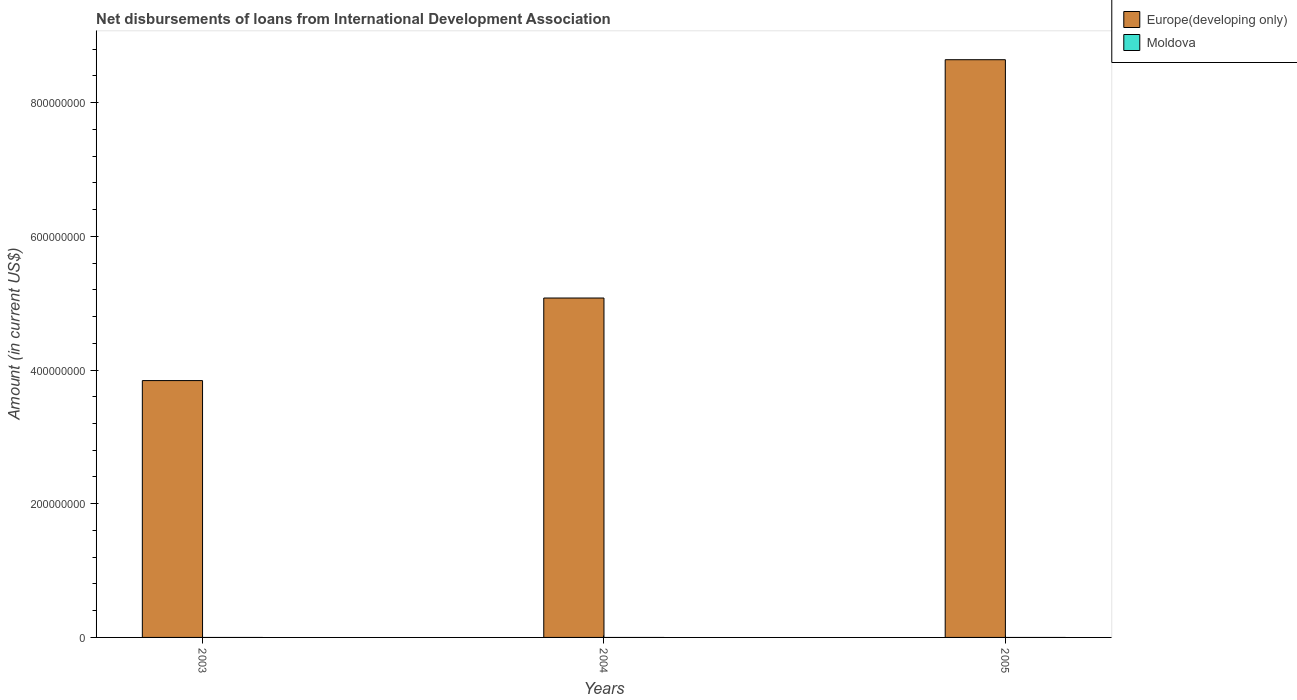What is the label of the 1st group of bars from the left?
Offer a terse response. 2003. What is the amount of loans disbursed in Moldova in 2005?
Your answer should be very brief. 0. Across all years, what is the maximum amount of loans disbursed in Europe(developing only)?
Your response must be concise. 8.64e+08. What is the total amount of loans disbursed in Moldova in the graph?
Offer a terse response. 0. What is the difference between the amount of loans disbursed in Europe(developing only) in 2003 and that in 2004?
Provide a succinct answer. -1.24e+08. What is the difference between the amount of loans disbursed in Moldova in 2005 and the amount of loans disbursed in Europe(developing only) in 2004?
Your response must be concise. -5.08e+08. What is the average amount of loans disbursed in Europe(developing only) per year?
Give a very brief answer. 5.85e+08. What is the ratio of the amount of loans disbursed in Europe(developing only) in 2004 to that in 2005?
Your answer should be very brief. 0.59. Is the amount of loans disbursed in Europe(developing only) in 2003 less than that in 2004?
Keep it short and to the point. Yes. What is the difference between the highest and the second highest amount of loans disbursed in Europe(developing only)?
Give a very brief answer. 3.56e+08. What is the difference between the highest and the lowest amount of loans disbursed in Europe(developing only)?
Provide a short and direct response. 4.80e+08. In how many years, is the amount of loans disbursed in Europe(developing only) greater than the average amount of loans disbursed in Europe(developing only) taken over all years?
Your answer should be compact. 1. How many bars are there?
Offer a very short reply. 3. Are all the bars in the graph horizontal?
Ensure brevity in your answer.  No. How many years are there in the graph?
Keep it short and to the point. 3. What is the difference between two consecutive major ticks on the Y-axis?
Keep it short and to the point. 2.00e+08. Does the graph contain grids?
Give a very brief answer. No. Where does the legend appear in the graph?
Offer a terse response. Top right. How are the legend labels stacked?
Ensure brevity in your answer.  Vertical. What is the title of the graph?
Keep it short and to the point. Net disbursements of loans from International Development Association. What is the label or title of the Y-axis?
Provide a short and direct response. Amount (in current US$). What is the Amount (in current US$) of Europe(developing only) in 2003?
Give a very brief answer. 3.84e+08. What is the Amount (in current US$) in Moldova in 2003?
Offer a terse response. 0. What is the Amount (in current US$) of Europe(developing only) in 2004?
Keep it short and to the point. 5.08e+08. What is the Amount (in current US$) of Europe(developing only) in 2005?
Give a very brief answer. 8.64e+08. What is the Amount (in current US$) of Moldova in 2005?
Your answer should be compact. 0. Across all years, what is the maximum Amount (in current US$) in Europe(developing only)?
Your answer should be very brief. 8.64e+08. Across all years, what is the minimum Amount (in current US$) in Europe(developing only)?
Your answer should be compact. 3.84e+08. What is the total Amount (in current US$) in Europe(developing only) in the graph?
Make the answer very short. 1.76e+09. What is the total Amount (in current US$) in Moldova in the graph?
Give a very brief answer. 0. What is the difference between the Amount (in current US$) of Europe(developing only) in 2003 and that in 2004?
Keep it short and to the point. -1.24e+08. What is the difference between the Amount (in current US$) in Europe(developing only) in 2003 and that in 2005?
Give a very brief answer. -4.80e+08. What is the difference between the Amount (in current US$) in Europe(developing only) in 2004 and that in 2005?
Provide a succinct answer. -3.56e+08. What is the average Amount (in current US$) in Europe(developing only) per year?
Keep it short and to the point. 5.85e+08. What is the average Amount (in current US$) of Moldova per year?
Offer a very short reply. 0. What is the ratio of the Amount (in current US$) of Europe(developing only) in 2003 to that in 2004?
Your answer should be compact. 0.76. What is the ratio of the Amount (in current US$) of Europe(developing only) in 2003 to that in 2005?
Keep it short and to the point. 0.44. What is the ratio of the Amount (in current US$) of Europe(developing only) in 2004 to that in 2005?
Your response must be concise. 0.59. What is the difference between the highest and the second highest Amount (in current US$) of Europe(developing only)?
Offer a terse response. 3.56e+08. What is the difference between the highest and the lowest Amount (in current US$) in Europe(developing only)?
Offer a terse response. 4.80e+08. 